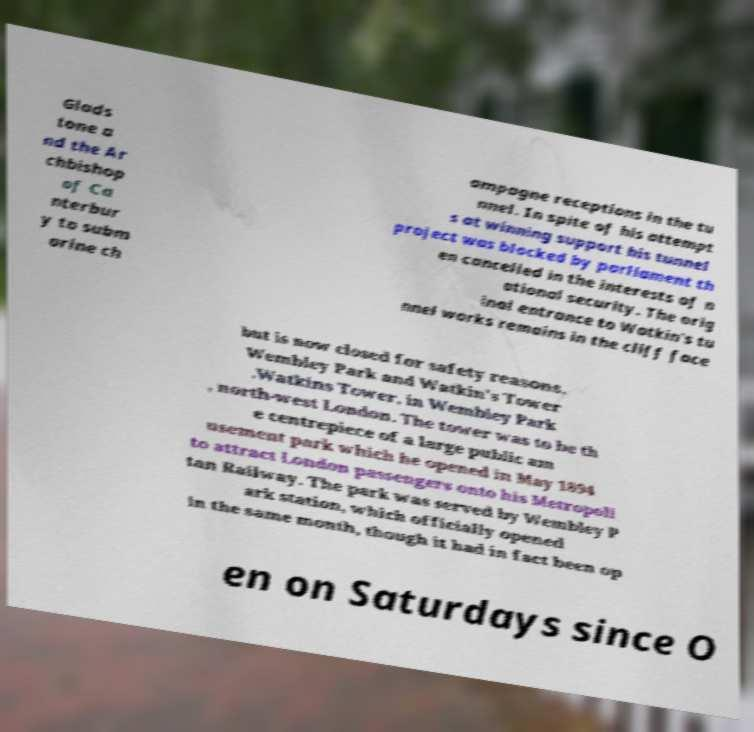Please read and relay the text visible in this image. What does it say? Glads tone a nd the Ar chbishop of Ca nterbur y to subm arine ch ampagne receptions in the tu nnel. In spite of his attempt s at winning support his tunnel project was blocked by parliament th en cancelled in the interests of n ational security. The orig inal entrance to Watkin's tu nnel works remains in the cliff face but is now closed for safety reasons. Wembley Park and Watkin's Tower .Watkins Tower, in Wembley Park , north-west London. The tower was to be th e centrepiece of a large public am usement park which he opened in May 1894 to attract London passengers onto his Metropoli tan Railway. The park was served by Wembley P ark station, which officially opened in the same month, though it had in fact been op en on Saturdays since O 